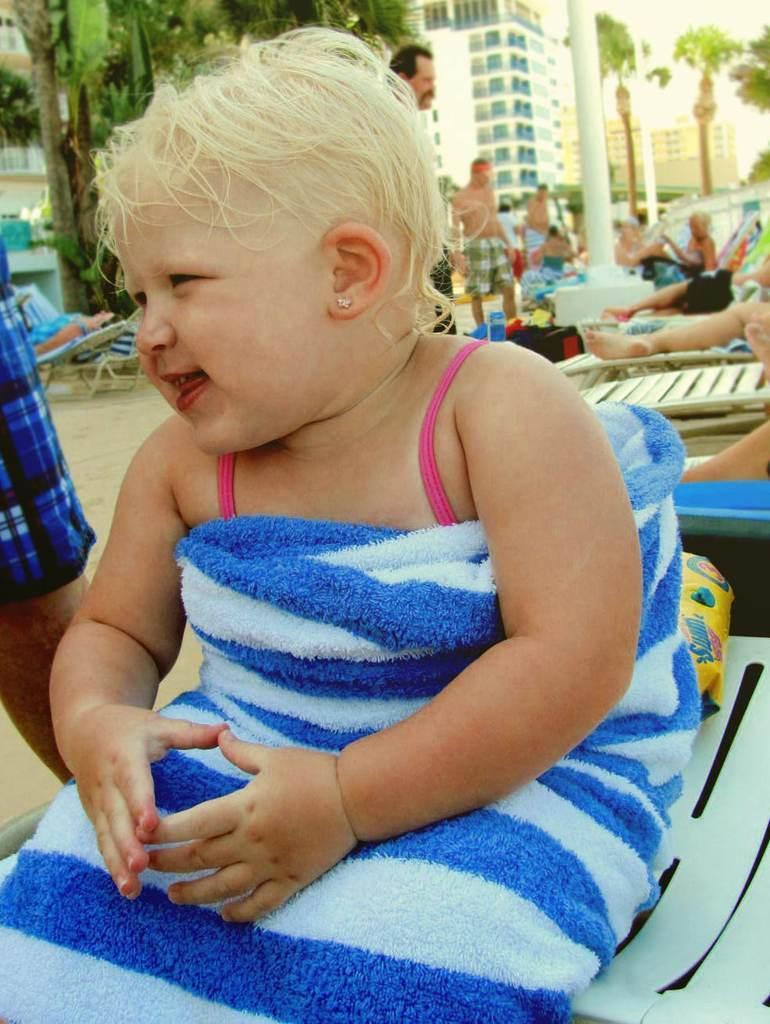In one or two sentences, can you explain what this image depicts? In the foreground of the picture there is a kid sitting on a chair, behind there are people, beach chairs, bags and trees. In the background there are buildings and trees. On the left there is a person hand. 